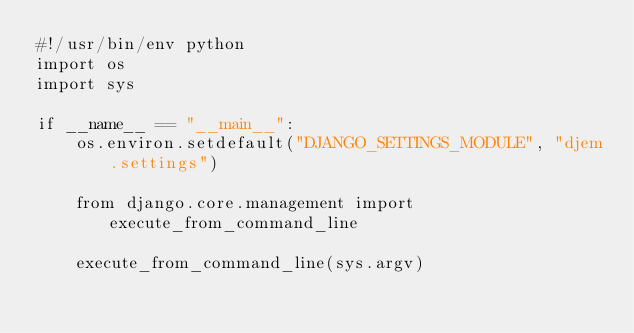<code> <loc_0><loc_0><loc_500><loc_500><_Python_>#!/usr/bin/env python
import os
import sys

if __name__ == "__main__":
    os.environ.setdefault("DJANGO_SETTINGS_MODULE", "djem.settings")

    from django.core.management import execute_from_command_line

    execute_from_command_line(sys.argv)
</code> 